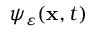Convert formula to latex. <formula><loc_0><loc_0><loc_500><loc_500>\psi _ { \varepsilon } ( x , t )</formula> 